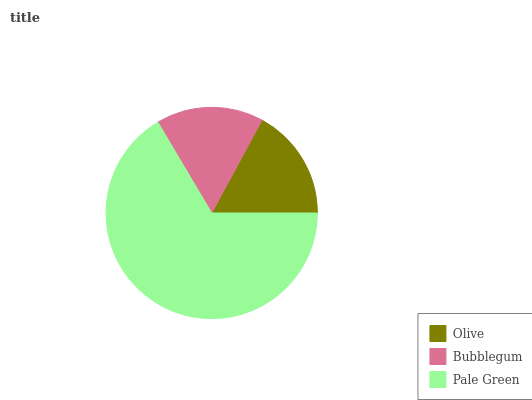Is Bubblegum the minimum?
Answer yes or no. Yes. Is Pale Green the maximum?
Answer yes or no. Yes. Is Pale Green the minimum?
Answer yes or no. No. Is Bubblegum the maximum?
Answer yes or no. No. Is Pale Green greater than Bubblegum?
Answer yes or no. Yes. Is Bubblegum less than Pale Green?
Answer yes or no. Yes. Is Bubblegum greater than Pale Green?
Answer yes or no. No. Is Pale Green less than Bubblegum?
Answer yes or no. No. Is Olive the high median?
Answer yes or no. Yes. Is Olive the low median?
Answer yes or no. Yes. Is Pale Green the high median?
Answer yes or no. No. Is Pale Green the low median?
Answer yes or no. No. 